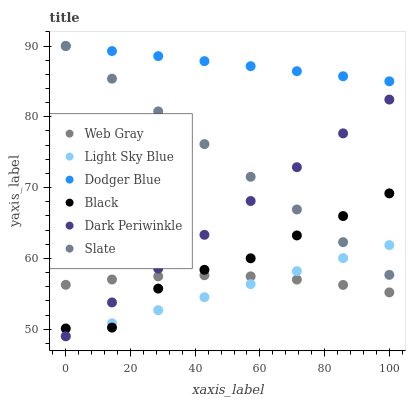Does Light Sky Blue have the minimum area under the curve?
Answer yes or no. Yes. Does Dodger Blue have the maximum area under the curve?
Answer yes or no. Yes. Does Slate have the minimum area under the curve?
Answer yes or no. No. Does Slate have the maximum area under the curve?
Answer yes or no. No. Is Dodger Blue the smoothest?
Answer yes or no. Yes. Is Black the roughest?
Answer yes or no. Yes. Is Slate the smoothest?
Answer yes or no. No. Is Slate the roughest?
Answer yes or no. No. Does Light Sky Blue have the lowest value?
Answer yes or no. Yes. Does Slate have the lowest value?
Answer yes or no. No. Does Dodger Blue have the highest value?
Answer yes or no. Yes. Does Light Sky Blue have the highest value?
Answer yes or no. No. Is Black less than Dodger Blue?
Answer yes or no. Yes. Is Dodger Blue greater than Light Sky Blue?
Answer yes or no. Yes. Does Web Gray intersect Light Sky Blue?
Answer yes or no. Yes. Is Web Gray less than Light Sky Blue?
Answer yes or no. No. Is Web Gray greater than Light Sky Blue?
Answer yes or no. No. Does Black intersect Dodger Blue?
Answer yes or no. No. 